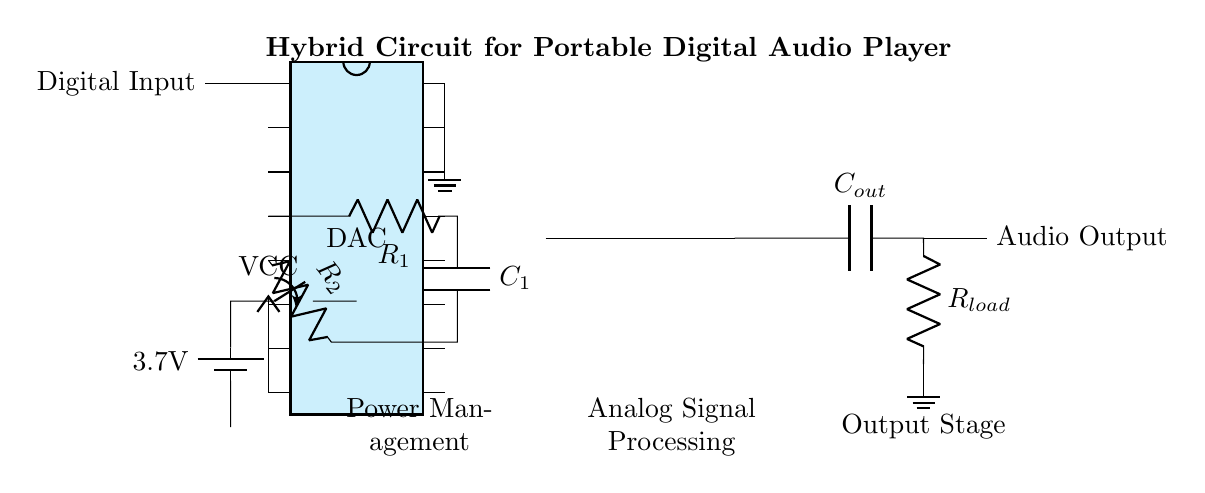What is the total number of pins on the DAC? The DAC has 16 pins, as indicated in the diagram where it shows a chip with 'num pins=16'.
Answer: 16 What type of signal is fed into the DAC? The diagram shows 'Digital Input' connected to pin 1 of the DAC, indicating that the signal provided is digital.
Answer: Digital What is the value of the voltage provided by the battery? The battery in the circuit provides a voltage of 3.7V as labeled directly on the battery icon.
Answer: 3.7V Which components are part of the analog signal processing section? The statement asks for components between the DAC and the op amp, which include resistors R1 and R2, and capacitor C1.
Answer: R1, R2, C1 What component connects to the output stage after the op amp? The output stage is connected to a capacitor labeled Cout, which is the next component after the op amp.
Answer: Cout How is the audio signal outputted in this circuit? The circuit indicates an 'Audio Output' connection at the end, showing the signal is available at that point for output.
Answer: Audio Output What is the function of the op amp in this circuit? The op amp is used in analog signal processing to amplify the processed signal before it goes to the output stage.
Answer: Amplification 